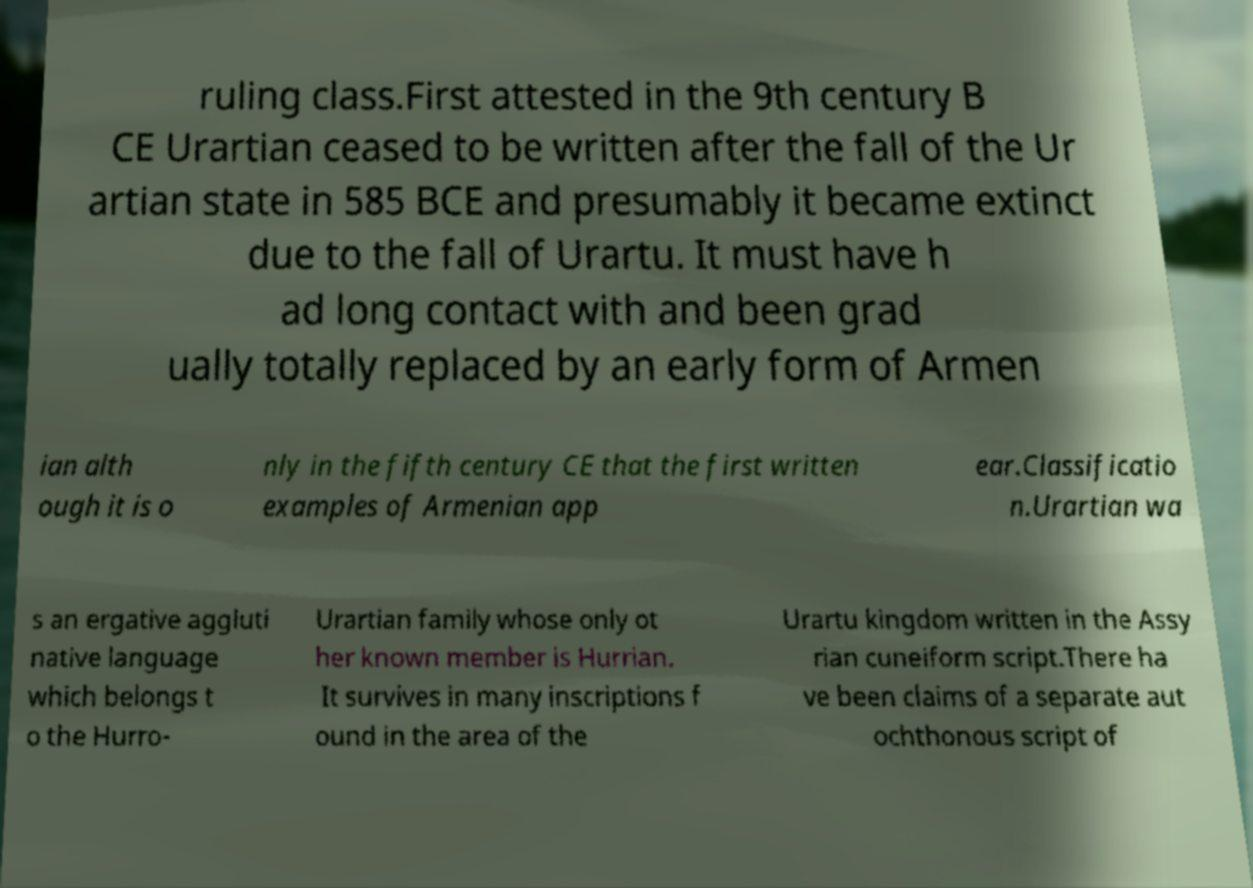Could you extract and type out the text from this image? ruling class.First attested in the 9th century B CE Urartian ceased to be written after the fall of the Ur artian state in 585 BCE and presumably it became extinct due to the fall of Urartu. It must have h ad long contact with and been grad ually totally replaced by an early form of Armen ian alth ough it is o nly in the fifth century CE that the first written examples of Armenian app ear.Classificatio n.Urartian wa s an ergative aggluti native language which belongs t o the Hurro- Urartian family whose only ot her known member is Hurrian. It survives in many inscriptions f ound in the area of the Urartu kingdom written in the Assy rian cuneiform script.There ha ve been claims of a separate aut ochthonous script of 